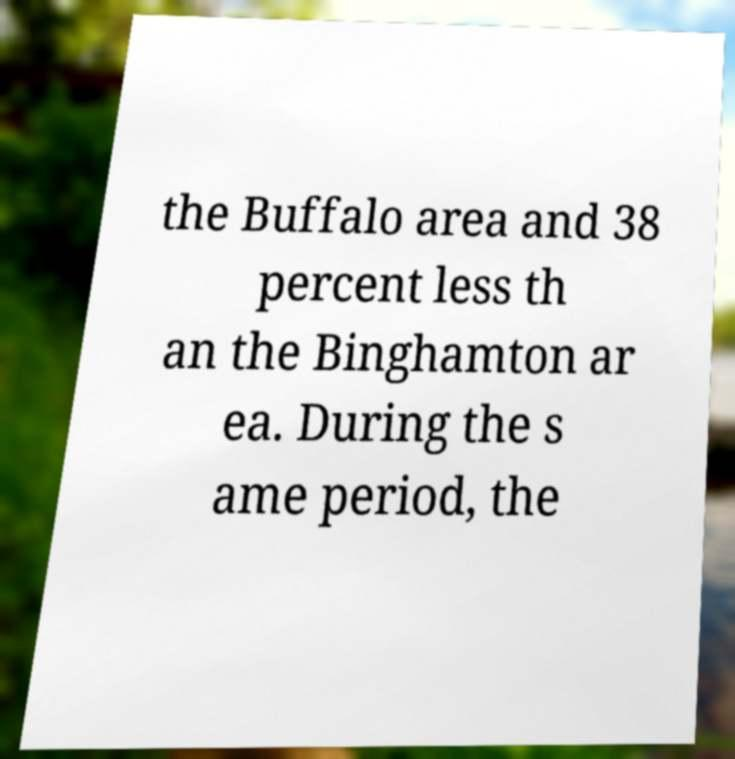Please identify and transcribe the text found in this image. the Buffalo area and 38 percent less th an the Binghamton ar ea. During the s ame period, the 